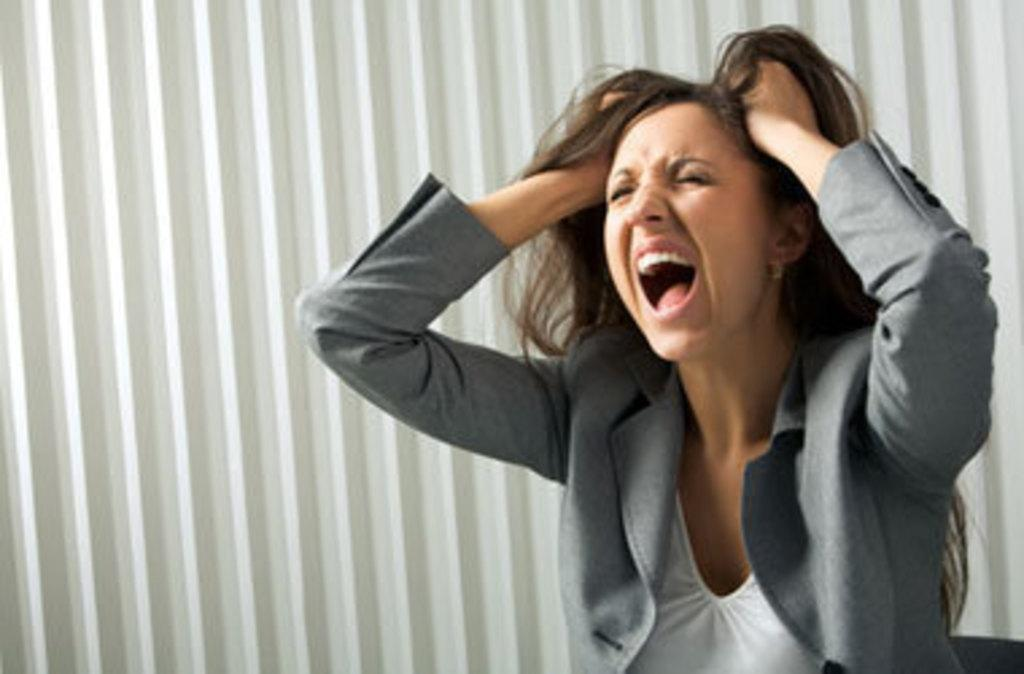Who is the main subject in the image? There is a woman in the image. What is the woman wearing? The woman is wearing a grey colored suit. What is the woman doing with her hands in the image? The woman has her hands on her head. What type of leaf is the woman holding in the image? There is no leaf present in the image; the woman is not holding anything. 